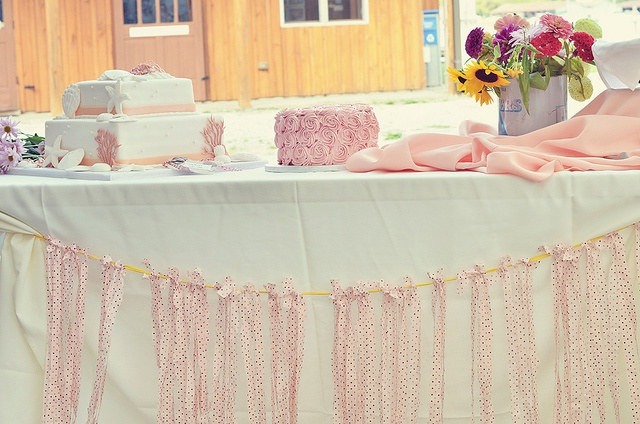Describe the objects in this image and their specific colors. I can see potted plant in gray, darkgray, olive, ivory, and khaki tones, cake in gray, lightpink, lightgray, tan, and brown tones, cake in gray, beige, darkgray, and tan tones, and vase in gray and darkgray tones in this image. 